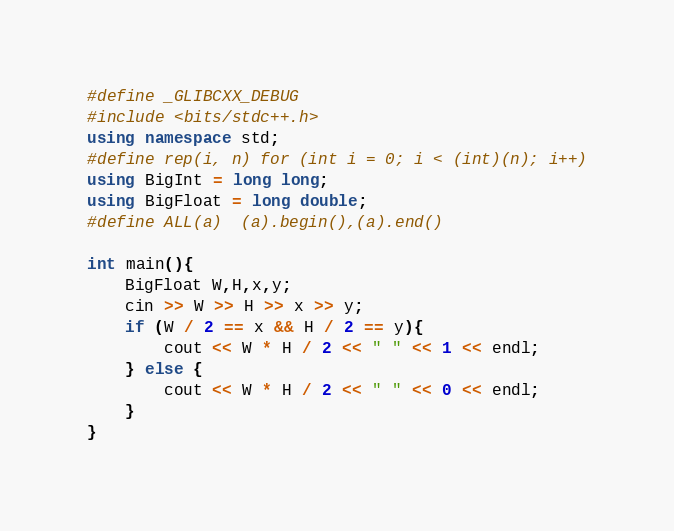Convert code to text. <code><loc_0><loc_0><loc_500><loc_500><_C++_>#define _GLIBCXX_DEBUG
#include <bits/stdc++.h>
using namespace std;
#define rep(i, n) for (int i = 0; i < (int)(n); i++)
using BigInt = long long;
using BigFloat = long double;
#define ALL(a)  (a).begin(),(a).end()
 
int main(){
    BigFloat W,H,x,y;
    cin >> W >> H >> x >> y;
    if (W / 2 == x && H / 2 == y){
        cout << W * H / 2 << " " << 1 << endl;
    } else {
        cout << W * H / 2 << " " << 0 << endl;
    }
}</code> 